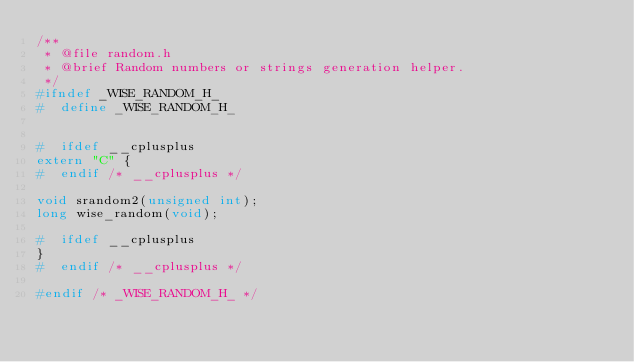<code> <loc_0><loc_0><loc_500><loc_500><_C_>/**
 * @file random.h
 * @brief Random numbers or strings generation helper.
 */
#ifndef _WISE_RANDOM_H_
#  define _WISE_RANDOM_H_


#  ifdef __cplusplus
extern "C" {
#  endif /* __cplusplus */

void srandom2(unsigned int);
long wise_random(void);

#  ifdef __cplusplus
}
#  endif /* __cplusplus */

#endif /* _WISE_RANDOM_H_ */
</code> 